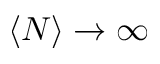Convert formula to latex. <formula><loc_0><loc_0><loc_500><loc_500>\left \langle N \right \rangle \to \infty</formula> 